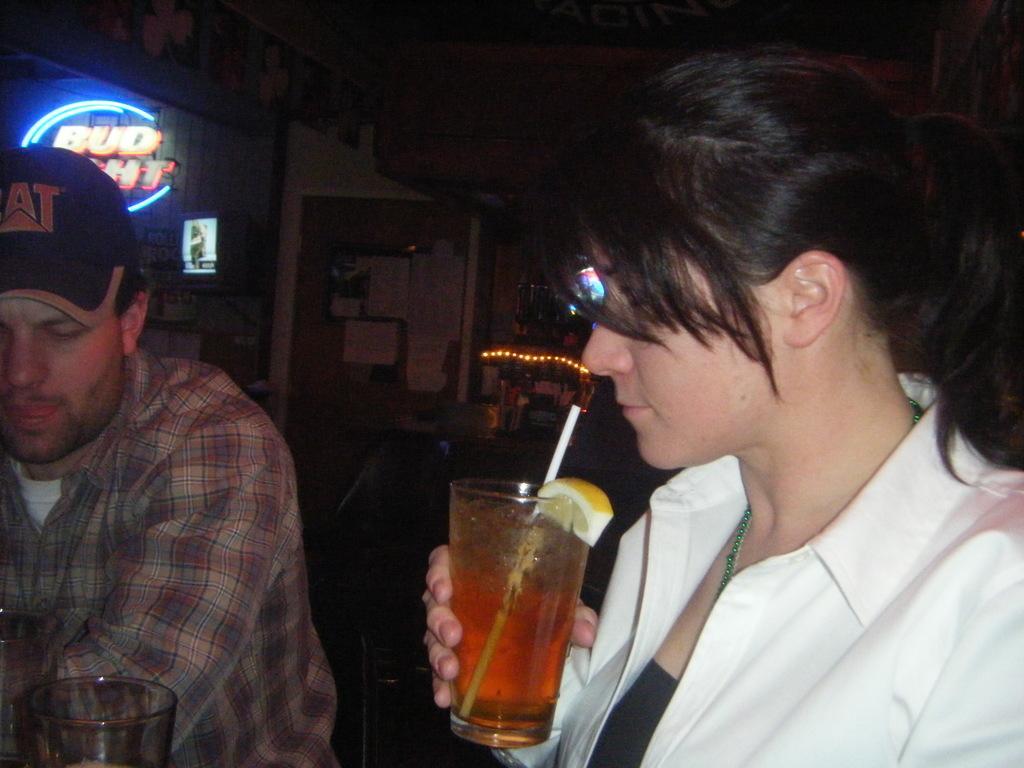Please provide a concise description of this image. In this picture we can see few people, on the right side of the image we can see a woman, she is holding a glass and we can find drink in the glass, in the background we can find a digital board and few papers, and also we can see few lights. 